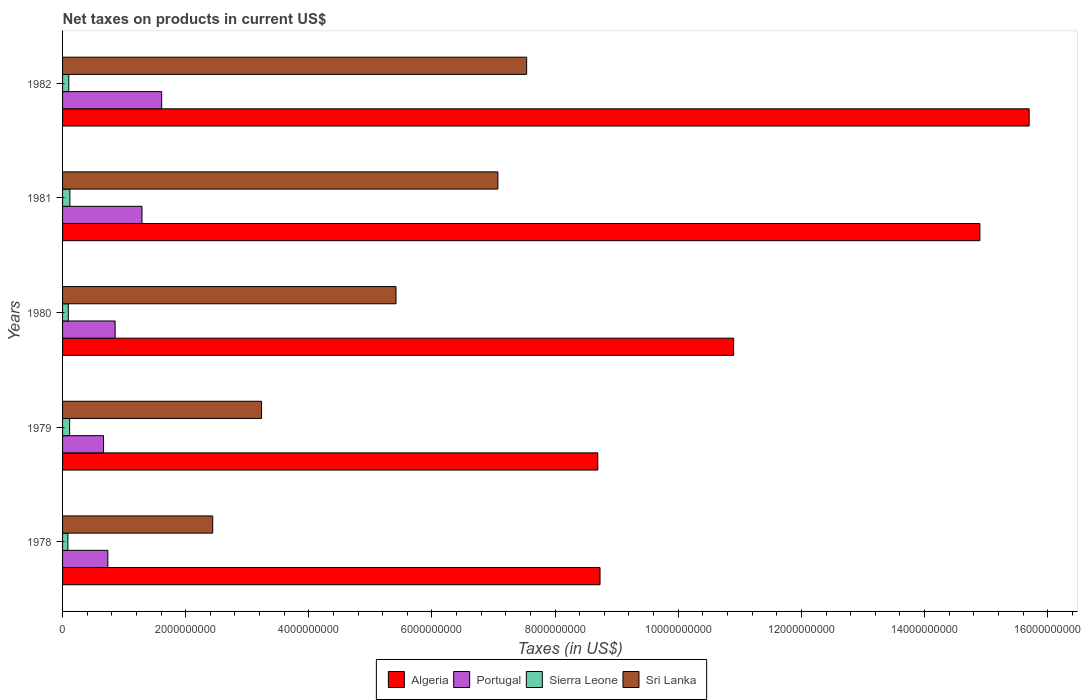Are the number of bars per tick equal to the number of legend labels?
Provide a succinct answer. Yes. Are the number of bars on each tick of the Y-axis equal?
Your response must be concise. Yes. How many bars are there on the 5th tick from the top?
Offer a very short reply. 4. How many bars are there on the 4th tick from the bottom?
Your answer should be very brief. 4. What is the label of the 5th group of bars from the top?
Provide a succinct answer. 1978. In how many cases, is the number of bars for a given year not equal to the number of legend labels?
Offer a very short reply. 0. What is the net taxes on products in Sri Lanka in 1980?
Offer a terse response. 5.42e+09. Across all years, what is the maximum net taxes on products in Algeria?
Give a very brief answer. 1.57e+1. Across all years, what is the minimum net taxes on products in Algeria?
Offer a terse response. 8.69e+09. In which year was the net taxes on products in Portugal maximum?
Ensure brevity in your answer.  1982. In which year was the net taxes on products in Algeria minimum?
Your answer should be compact. 1979. What is the total net taxes on products in Sierra Leone in the graph?
Provide a succinct answer. 5.14e+08. What is the difference between the net taxes on products in Sierra Leone in 1979 and that in 1982?
Your response must be concise. 1.37e+07. What is the difference between the net taxes on products in Portugal in 1981 and the net taxes on products in Algeria in 1979?
Your answer should be very brief. -7.40e+09. What is the average net taxes on products in Algeria per year?
Your answer should be very brief. 1.18e+1. In the year 1982, what is the difference between the net taxes on products in Algeria and net taxes on products in Sri Lanka?
Provide a short and direct response. 8.16e+09. In how many years, is the net taxes on products in Sierra Leone greater than 6400000000 US$?
Your answer should be compact. 0. What is the ratio of the net taxes on products in Algeria in 1981 to that in 1982?
Your answer should be compact. 0.95. What is the difference between the highest and the second highest net taxes on products in Sierra Leone?
Give a very brief answer. 4.32e+06. What is the difference between the highest and the lowest net taxes on products in Sri Lanka?
Give a very brief answer. 5.10e+09. In how many years, is the net taxes on products in Algeria greater than the average net taxes on products in Algeria taken over all years?
Provide a succinct answer. 2. What does the 1st bar from the top in 1978 represents?
Offer a very short reply. Sri Lanka. What does the 4th bar from the bottom in 1979 represents?
Your answer should be compact. Sri Lanka. How many years are there in the graph?
Offer a terse response. 5. Where does the legend appear in the graph?
Your answer should be compact. Bottom center. How many legend labels are there?
Give a very brief answer. 4. What is the title of the graph?
Your answer should be compact. Net taxes on products in current US$. What is the label or title of the X-axis?
Give a very brief answer. Taxes (in US$). What is the label or title of the Y-axis?
Provide a succinct answer. Years. What is the Taxes (in US$) in Algeria in 1978?
Offer a very short reply. 8.73e+09. What is the Taxes (in US$) of Portugal in 1978?
Give a very brief answer. 7.36e+08. What is the Taxes (in US$) in Sierra Leone in 1978?
Offer a very short reply. 8.65e+07. What is the Taxes (in US$) of Sri Lanka in 1978?
Offer a terse response. 2.44e+09. What is the Taxes (in US$) in Algeria in 1979?
Keep it short and to the point. 8.69e+09. What is the Taxes (in US$) of Portugal in 1979?
Offer a very short reply. 6.65e+08. What is the Taxes (in US$) in Sierra Leone in 1979?
Offer a very short reply. 1.15e+08. What is the Taxes (in US$) of Sri Lanka in 1979?
Offer a very short reply. 3.23e+09. What is the Taxes (in US$) in Algeria in 1980?
Your response must be concise. 1.09e+1. What is the Taxes (in US$) of Portugal in 1980?
Give a very brief answer. 8.54e+08. What is the Taxes (in US$) in Sierra Leone in 1980?
Offer a terse response. 9.30e+07. What is the Taxes (in US$) of Sri Lanka in 1980?
Your answer should be compact. 5.42e+09. What is the Taxes (in US$) in Algeria in 1981?
Make the answer very short. 1.49e+1. What is the Taxes (in US$) of Portugal in 1981?
Your response must be concise. 1.29e+09. What is the Taxes (in US$) in Sierra Leone in 1981?
Ensure brevity in your answer.  1.19e+08. What is the Taxes (in US$) of Sri Lanka in 1981?
Give a very brief answer. 7.07e+09. What is the Taxes (in US$) in Algeria in 1982?
Give a very brief answer. 1.57e+1. What is the Taxes (in US$) of Portugal in 1982?
Your response must be concise. 1.61e+09. What is the Taxes (in US$) in Sierra Leone in 1982?
Ensure brevity in your answer.  1.01e+08. What is the Taxes (in US$) in Sri Lanka in 1982?
Your answer should be compact. 7.54e+09. Across all years, what is the maximum Taxes (in US$) in Algeria?
Keep it short and to the point. 1.57e+1. Across all years, what is the maximum Taxes (in US$) of Portugal?
Your answer should be very brief. 1.61e+09. Across all years, what is the maximum Taxes (in US$) of Sierra Leone?
Give a very brief answer. 1.19e+08. Across all years, what is the maximum Taxes (in US$) of Sri Lanka?
Ensure brevity in your answer.  7.54e+09. Across all years, what is the minimum Taxes (in US$) in Algeria?
Your answer should be compact. 8.69e+09. Across all years, what is the minimum Taxes (in US$) of Portugal?
Keep it short and to the point. 6.65e+08. Across all years, what is the minimum Taxes (in US$) of Sierra Leone?
Your answer should be very brief. 8.65e+07. Across all years, what is the minimum Taxes (in US$) in Sri Lanka?
Offer a terse response. 2.44e+09. What is the total Taxes (in US$) of Algeria in the graph?
Provide a succinct answer. 5.89e+1. What is the total Taxes (in US$) in Portugal in the graph?
Provide a succinct answer. 5.15e+09. What is the total Taxes (in US$) in Sierra Leone in the graph?
Your answer should be compact. 5.14e+08. What is the total Taxes (in US$) of Sri Lanka in the graph?
Provide a short and direct response. 2.57e+1. What is the difference between the Taxes (in US$) in Algeria in 1978 and that in 1979?
Provide a succinct answer. 3.64e+07. What is the difference between the Taxes (in US$) in Portugal in 1978 and that in 1979?
Ensure brevity in your answer.  7.03e+07. What is the difference between the Taxes (in US$) in Sierra Leone in 1978 and that in 1979?
Make the answer very short. -2.82e+07. What is the difference between the Taxes (in US$) of Sri Lanka in 1978 and that in 1979?
Offer a very short reply. -7.93e+08. What is the difference between the Taxes (in US$) of Algeria in 1978 and that in 1980?
Keep it short and to the point. -2.17e+09. What is the difference between the Taxes (in US$) of Portugal in 1978 and that in 1980?
Your answer should be very brief. -1.18e+08. What is the difference between the Taxes (in US$) in Sierra Leone in 1978 and that in 1980?
Offer a very short reply. -6.53e+06. What is the difference between the Taxes (in US$) of Sri Lanka in 1978 and that in 1980?
Provide a short and direct response. -2.98e+09. What is the difference between the Taxes (in US$) in Algeria in 1978 and that in 1981?
Offer a terse response. -6.17e+09. What is the difference between the Taxes (in US$) in Portugal in 1978 and that in 1981?
Your answer should be very brief. -5.54e+08. What is the difference between the Taxes (in US$) of Sierra Leone in 1978 and that in 1981?
Offer a very short reply. -3.25e+07. What is the difference between the Taxes (in US$) in Sri Lanka in 1978 and that in 1981?
Give a very brief answer. -4.63e+09. What is the difference between the Taxes (in US$) in Algeria in 1978 and that in 1982?
Offer a very short reply. -6.97e+09. What is the difference between the Taxes (in US$) of Portugal in 1978 and that in 1982?
Provide a short and direct response. -8.74e+08. What is the difference between the Taxes (in US$) in Sierra Leone in 1978 and that in 1982?
Offer a terse response. -1.45e+07. What is the difference between the Taxes (in US$) in Sri Lanka in 1978 and that in 1982?
Your response must be concise. -5.10e+09. What is the difference between the Taxes (in US$) in Algeria in 1979 and that in 1980?
Provide a short and direct response. -2.21e+09. What is the difference between the Taxes (in US$) of Portugal in 1979 and that in 1980?
Make the answer very short. -1.89e+08. What is the difference between the Taxes (in US$) of Sierra Leone in 1979 and that in 1980?
Your answer should be compact. 2.17e+07. What is the difference between the Taxes (in US$) in Sri Lanka in 1979 and that in 1980?
Ensure brevity in your answer.  -2.18e+09. What is the difference between the Taxes (in US$) of Algeria in 1979 and that in 1981?
Your response must be concise. -6.21e+09. What is the difference between the Taxes (in US$) of Portugal in 1979 and that in 1981?
Give a very brief answer. -6.25e+08. What is the difference between the Taxes (in US$) of Sierra Leone in 1979 and that in 1981?
Keep it short and to the point. -4.32e+06. What is the difference between the Taxes (in US$) of Sri Lanka in 1979 and that in 1981?
Give a very brief answer. -3.84e+09. What is the difference between the Taxes (in US$) of Algeria in 1979 and that in 1982?
Your response must be concise. -7.01e+09. What is the difference between the Taxes (in US$) of Portugal in 1979 and that in 1982?
Offer a very short reply. -9.44e+08. What is the difference between the Taxes (in US$) in Sierra Leone in 1979 and that in 1982?
Give a very brief answer. 1.37e+07. What is the difference between the Taxes (in US$) of Sri Lanka in 1979 and that in 1982?
Give a very brief answer. -4.31e+09. What is the difference between the Taxes (in US$) in Algeria in 1980 and that in 1981?
Your answer should be compact. -4.00e+09. What is the difference between the Taxes (in US$) in Portugal in 1980 and that in 1981?
Ensure brevity in your answer.  -4.36e+08. What is the difference between the Taxes (in US$) of Sierra Leone in 1980 and that in 1981?
Offer a terse response. -2.60e+07. What is the difference between the Taxes (in US$) of Sri Lanka in 1980 and that in 1981?
Your answer should be compact. -1.66e+09. What is the difference between the Taxes (in US$) of Algeria in 1980 and that in 1982?
Give a very brief answer. -4.80e+09. What is the difference between the Taxes (in US$) in Portugal in 1980 and that in 1982?
Your answer should be compact. -7.56e+08. What is the difference between the Taxes (in US$) of Sierra Leone in 1980 and that in 1982?
Your answer should be compact. -8.00e+06. What is the difference between the Taxes (in US$) of Sri Lanka in 1980 and that in 1982?
Your answer should be very brief. -2.12e+09. What is the difference between the Taxes (in US$) of Algeria in 1981 and that in 1982?
Keep it short and to the point. -8.00e+08. What is the difference between the Taxes (in US$) in Portugal in 1981 and that in 1982?
Give a very brief answer. -3.20e+08. What is the difference between the Taxes (in US$) in Sierra Leone in 1981 and that in 1982?
Provide a short and direct response. 1.80e+07. What is the difference between the Taxes (in US$) in Sri Lanka in 1981 and that in 1982?
Provide a short and direct response. -4.67e+08. What is the difference between the Taxes (in US$) in Algeria in 1978 and the Taxes (in US$) in Portugal in 1979?
Ensure brevity in your answer.  8.06e+09. What is the difference between the Taxes (in US$) of Algeria in 1978 and the Taxes (in US$) of Sierra Leone in 1979?
Make the answer very short. 8.62e+09. What is the difference between the Taxes (in US$) of Algeria in 1978 and the Taxes (in US$) of Sri Lanka in 1979?
Keep it short and to the point. 5.50e+09. What is the difference between the Taxes (in US$) of Portugal in 1978 and the Taxes (in US$) of Sierra Leone in 1979?
Your answer should be very brief. 6.21e+08. What is the difference between the Taxes (in US$) of Portugal in 1978 and the Taxes (in US$) of Sri Lanka in 1979?
Offer a terse response. -2.50e+09. What is the difference between the Taxes (in US$) in Sierra Leone in 1978 and the Taxes (in US$) in Sri Lanka in 1979?
Ensure brevity in your answer.  -3.15e+09. What is the difference between the Taxes (in US$) in Algeria in 1978 and the Taxes (in US$) in Portugal in 1980?
Ensure brevity in your answer.  7.88e+09. What is the difference between the Taxes (in US$) of Algeria in 1978 and the Taxes (in US$) of Sierra Leone in 1980?
Provide a succinct answer. 8.64e+09. What is the difference between the Taxes (in US$) in Algeria in 1978 and the Taxes (in US$) in Sri Lanka in 1980?
Your answer should be very brief. 3.31e+09. What is the difference between the Taxes (in US$) in Portugal in 1978 and the Taxes (in US$) in Sierra Leone in 1980?
Your answer should be compact. 6.43e+08. What is the difference between the Taxes (in US$) in Portugal in 1978 and the Taxes (in US$) in Sri Lanka in 1980?
Give a very brief answer. -4.68e+09. What is the difference between the Taxes (in US$) in Sierra Leone in 1978 and the Taxes (in US$) in Sri Lanka in 1980?
Offer a terse response. -5.33e+09. What is the difference between the Taxes (in US$) in Algeria in 1978 and the Taxes (in US$) in Portugal in 1981?
Provide a succinct answer. 7.44e+09. What is the difference between the Taxes (in US$) of Algeria in 1978 and the Taxes (in US$) of Sierra Leone in 1981?
Make the answer very short. 8.61e+09. What is the difference between the Taxes (in US$) in Algeria in 1978 and the Taxes (in US$) in Sri Lanka in 1981?
Offer a very short reply. 1.66e+09. What is the difference between the Taxes (in US$) of Portugal in 1978 and the Taxes (in US$) of Sierra Leone in 1981?
Keep it short and to the point. 6.17e+08. What is the difference between the Taxes (in US$) in Portugal in 1978 and the Taxes (in US$) in Sri Lanka in 1981?
Your answer should be compact. -6.34e+09. What is the difference between the Taxes (in US$) in Sierra Leone in 1978 and the Taxes (in US$) in Sri Lanka in 1981?
Keep it short and to the point. -6.98e+09. What is the difference between the Taxes (in US$) of Algeria in 1978 and the Taxes (in US$) of Portugal in 1982?
Your answer should be compact. 7.12e+09. What is the difference between the Taxes (in US$) in Algeria in 1978 and the Taxes (in US$) in Sierra Leone in 1982?
Offer a very short reply. 8.63e+09. What is the difference between the Taxes (in US$) in Algeria in 1978 and the Taxes (in US$) in Sri Lanka in 1982?
Make the answer very short. 1.19e+09. What is the difference between the Taxes (in US$) in Portugal in 1978 and the Taxes (in US$) in Sierra Leone in 1982?
Your response must be concise. 6.35e+08. What is the difference between the Taxes (in US$) of Portugal in 1978 and the Taxes (in US$) of Sri Lanka in 1982?
Your response must be concise. -6.80e+09. What is the difference between the Taxes (in US$) of Sierra Leone in 1978 and the Taxes (in US$) of Sri Lanka in 1982?
Make the answer very short. -7.45e+09. What is the difference between the Taxes (in US$) of Algeria in 1979 and the Taxes (in US$) of Portugal in 1980?
Your response must be concise. 7.84e+09. What is the difference between the Taxes (in US$) of Algeria in 1979 and the Taxes (in US$) of Sierra Leone in 1980?
Provide a succinct answer. 8.60e+09. What is the difference between the Taxes (in US$) in Algeria in 1979 and the Taxes (in US$) in Sri Lanka in 1980?
Ensure brevity in your answer.  3.28e+09. What is the difference between the Taxes (in US$) of Portugal in 1979 and the Taxes (in US$) of Sierra Leone in 1980?
Provide a short and direct response. 5.72e+08. What is the difference between the Taxes (in US$) of Portugal in 1979 and the Taxes (in US$) of Sri Lanka in 1980?
Keep it short and to the point. -4.75e+09. What is the difference between the Taxes (in US$) of Sierra Leone in 1979 and the Taxes (in US$) of Sri Lanka in 1980?
Make the answer very short. -5.30e+09. What is the difference between the Taxes (in US$) in Algeria in 1979 and the Taxes (in US$) in Portugal in 1981?
Offer a terse response. 7.40e+09. What is the difference between the Taxes (in US$) in Algeria in 1979 and the Taxes (in US$) in Sierra Leone in 1981?
Provide a short and direct response. 8.57e+09. What is the difference between the Taxes (in US$) of Algeria in 1979 and the Taxes (in US$) of Sri Lanka in 1981?
Your response must be concise. 1.62e+09. What is the difference between the Taxes (in US$) in Portugal in 1979 and the Taxes (in US$) in Sierra Leone in 1981?
Your response must be concise. 5.46e+08. What is the difference between the Taxes (in US$) of Portugal in 1979 and the Taxes (in US$) of Sri Lanka in 1981?
Offer a terse response. -6.41e+09. What is the difference between the Taxes (in US$) of Sierra Leone in 1979 and the Taxes (in US$) of Sri Lanka in 1981?
Provide a short and direct response. -6.96e+09. What is the difference between the Taxes (in US$) of Algeria in 1979 and the Taxes (in US$) of Portugal in 1982?
Your answer should be very brief. 7.08e+09. What is the difference between the Taxes (in US$) of Algeria in 1979 and the Taxes (in US$) of Sierra Leone in 1982?
Provide a short and direct response. 8.59e+09. What is the difference between the Taxes (in US$) of Algeria in 1979 and the Taxes (in US$) of Sri Lanka in 1982?
Your answer should be very brief. 1.16e+09. What is the difference between the Taxes (in US$) of Portugal in 1979 and the Taxes (in US$) of Sierra Leone in 1982?
Offer a very short reply. 5.64e+08. What is the difference between the Taxes (in US$) of Portugal in 1979 and the Taxes (in US$) of Sri Lanka in 1982?
Your answer should be compact. -6.87e+09. What is the difference between the Taxes (in US$) of Sierra Leone in 1979 and the Taxes (in US$) of Sri Lanka in 1982?
Your answer should be very brief. -7.42e+09. What is the difference between the Taxes (in US$) in Algeria in 1980 and the Taxes (in US$) in Portugal in 1981?
Your answer should be very brief. 9.61e+09. What is the difference between the Taxes (in US$) of Algeria in 1980 and the Taxes (in US$) of Sierra Leone in 1981?
Make the answer very short. 1.08e+1. What is the difference between the Taxes (in US$) of Algeria in 1980 and the Taxes (in US$) of Sri Lanka in 1981?
Ensure brevity in your answer.  3.83e+09. What is the difference between the Taxes (in US$) of Portugal in 1980 and the Taxes (in US$) of Sierra Leone in 1981?
Your response must be concise. 7.35e+08. What is the difference between the Taxes (in US$) in Portugal in 1980 and the Taxes (in US$) in Sri Lanka in 1981?
Keep it short and to the point. -6.22e+09. What is the difference between the Taxes (in US$) in Sierra Leone in 1980 and the Taxes (in US$) in Sri Lanka in 1981?
Offer a terse response. -6.98e+09. What is the difference between the Taxes (in US$) of Algeria in 1980 and the Taxes (in US$) of Portugal in 1982?
Offer a terse response. 9.29e+09. What is the difference between the Taxes (in US$) in Algeria in 1980 and the Taxes (in US$) in Sierra Leone in 1982?
Your response must be concise. 1.08e+1. What is the difference between the Taxes (in US$) in Algeria in 1980 and the Taxes (in US$) in Sri Lanka in 1982?
Your response must be concise. 3.36e+09. What is the difference between the Taxes (in US$) of Portugal in 1980 and the Taxes (in US$) of Sierra Leone in 1982?
Give a very brief answer. 7.53e+08. What is the difference between the Taxes (in US$) of Portugal in 1980 and the Taxes (in US$) of Sri Lanka in 1982?
Provide a succinct answer. -6.68e+09. What is the difference between the Taxes (in US$) of Sierra Leone in 1980 and the Taxes (in US$) of Sri Lanka in 1982?
Give a very brief answer. -7.44e+09. What is the difference between the Taxes (in US$) of Algeria in 1981 and the Taxes (in US$) of Portugal in 1982?
Offer a very short reply. 1.33e+1. What is the difference between the Taxes (in US$) in Algeria in 1981 and the Taxes (in US$) in Sierra Leone in 1982?
Offer a terse response. 1.48e+1. What is the difference between the Taxes (in US$) of Algeria in 1981 and the Taxes (in US$) of Sri Lanka in 1982?
Give a very brief answer. 7.36e+09. What is the difference between the Taxes (in US$) in Portugal in 1981 and the Taxes (in US$) in Sierra Leone in 1982?
Keep it short and to the point. 1.19e+09. What is the difference between the Taxes (in US$) in Portugal in 1981 and the Taxes (in US$) in Sri Lanka in 1982?
Keep it short and to the point. -6.25e+09. What is the difference between the Taxes (in US$) of Sierra Leone in 1981 and the Taxes (in US$) of Sri Lanka in 1982?
Offer a terse response. -7.42e+09. What is the average Taxes (in US$) in Algeria per year?
Offer a terse response. 1.18e+1. What is the average Taxes (in US$) of Portugal per year?
Your answer should be very brief. 1.03e+09. What is the average Taxes (in US$) of Sierra Leone per year?
Your answer should be very brief. 1.03e+08. What is the average Taxes (in US$) of Sri Lanka per year?
Provide a short and direct response. 5.14e+09. In the year 1978, what is the difference between the Taxes (in US$) in Algeria and Taxes (in US$) in Portugal?
Keep it short and to the point. 7.99e+09. In the year 1978, what is the difference between the Taxes (in US$) in Algeria and Taxes (in US$) in Sierra Leone?
Offer a terse response. 8.64e+09. In the year 1978, what is the difference between the Taxes (in US$) in Algeria and Taxes (in US$) in Sri Lanka?
Offer a very short reply. 6.29e+09. In the year 1978, what is the difference between the Taxes (in US$) of Portugal and Taxes (in US$) of Sierra Leone?
Your answer should be compact. 6.49e+08. In the year 1978, what is the difference between the Taxes (in US$) in Portugal and Taxes (in US$) in Sri Lanka?
Provide a short and direct response. -1.70e+09. In the year 1978, what is the difference between the Taxes (in US$) in Sierra Leone and Taxes (in US$) in Sri Lanka?
Your response must be concise. -2.35e+09. In the year 1979, what is the difference between the Taxes (in US$) in Algeria and Taxes (in US$) in Portugal?
Keep it short and to the point. 8.03e+09. In the year 1979, what is the difference between the Taxes (in US$) in Algeria and Taxes (in US$) in Sierra Leone?
Give a very brief answer. 8.58e+09. In the year 1979, what is the difference between the Taxes (in US$) of Algeria and Taxes (in US$) of Sri Lanka?
Provide a short and direct response. 5.46e+09. In the year 1979, what is the difference between the Taxes (in US$) of Portugal and Taxes (in US$) of Sierra Leone?
Your answer should be compact. 5.51e+08. In the year 1979, what is the difference between the Taxes (in US$) of Portugal and Taxes (in US$) of Sri Lanka?
Offer a terse response. -2.57e+09. In the year 1979, what is the difference between the Taxes (in US$) in Sierra Leone and Taxes (in US$) in Sri Lanka?
Make the answer very short. -3.12e+09. In the year 1980, what is the difference between the Taxes (in US$) in Algeria and Taxes (in US$) in Portugal?
Your answer should be very brief. 1.00e+1. In the year 1980, what is the difference between the Taxes (in US$) of Algeria and Taxes (in US$) of Sierra Leone?
Make the answer very short. 1.08e+1. In the year 1980, what is the difference between the Taxes (in US$) in Algeria and Taxes (in US$) in Sri Lanka?
Provide a succinct answer. 5.48e+09. In the year 1980, what is the difference between the Taxes (in US$) of Portugal and Taxes (in US$) of Sierra Leone?
Your answer should be compact. 7.61e+08. In the year 1980, what is the difference between the Taxes (in US$) of Portugal and Taxes (in US$) of Sri Lanka?
Provide a short and direct response. -4.56e+09. In the year 1980, what is the difference between the Taxes (in US$) in Sierra Leone and Taxes (in US$) in Sri Lanka?
Ensure brevity in your answer.  -5.32e+09. In the year 1981, what is the difference between the Taxes (in US$) in Algeria and Taxes (in US$) in Portugal?
Make the answer very short. 1.36e+1. In the year 1981, what is the difference between the Taxes (in US$) in Algeria and Taxes (in US$) in Sierra Leone?
Give a very brief answer. 1.48e+1. In the year 1981, what is the difference between the Taxes (in US$) in Algeria and Taxes (in US$) in Sri Lanka?
Offer a terse response. 7.83e+09. In the year 1981, what is the difference between the Taxes (in US$) in Portugal and Taxes (in US$) in Sierra Leone?
Provide a short and direct response. 1.17e+09. In the year 1981, what is the difference between the Taxes (in US$) of Portugal and Taxes (in US$) of Sri Lanka?
Your answer should be compact. -5.78e+09. In the year 1981, what is the difference between the Taxes (in US$) of Sierra Leone and Taxes (in US$) of Sri Lanka?
Offer a very short reply. -6.95e+09. In the year 1982, what is the difference between the Taxes (in US$) in Algeria and Taxes (in US$) in Portugal?
Give a very brief answer. 1.41e+1. In the year 1982, what is the difference between the Taxes (in US$) of Algeria and Taxes (in US$) of Sierra Leone?
Provide a short and direct response. 1.56e+1. In the year 1982, what is the difference between the Taxes (in US$) of Algeria and Taxes (in US$) of Sri Lanka?
Provide a short and direct response. 8.16e+09. In the year 1982, what is the difference between the Taxes (in US$) in Portugal and Taxes (in US$) in Sierra Leone?
Your response must be concise. 1.51e+09. In the year 1982, what is the difference between the Taxes (in US$) of Portugal and Taxes (in US$) of Sri Lanka?
Your answer should be compact. -5.93e+09. In the year 1982, what is the difference between the Taxes (in US$) of Sierra Leone and Taxes (in US$) of Sri Lanka?
Keep it short and to the point. -7.44e+09. What is the ratio of the Taxes (in US$) in Portugal in 1978 to that in 1979?
Your response must be concise. 1.11. What is the ratio of the Taxes (in US$) in Sierra Leone in 1978 to that in 1979?
Make the answer very short. 0.75. What is the ratio of the Taxes (in US$) of Sri Lanka in 1978 to that in 1979?
Give a very brief answer. 0.75. What is the ratio of the Taxes (in US$) of Algeria in 1978 to that in 1980?
Your answer should be compact. 0.8. What is the ratio of the Taxes (in US$) in Portugal in 1978 to that in 1980?
Provide a short and direct response. 0.86. What is the ratio of the Taxes (in US$) in Sierra Leone in 1978 to that in 1980?
Your response must be concise. 0.93. What is the ratio of the Taxes (in US$) of Sri Lanka in 1978 to that in 1980?
Offer a terse response. 0.45. What is the ratio of the Taxes (in US$) in Algeria in 1978 to that in 1981?
Keep it short and to the point. 0.59. What is the ratio of the Taxes (in US$) of Portugal in 1978 to that in 1981?
Your answer should be very brief. 0.57. What is the ratio of the Taxes (in US$) of Sierra Leone in 1978 to that in 1981?
Your answer should be very brief. 0.73. What is the ratio of the Taxes (in US$) of Sri Lanka in 1978 to that in 1981?
Your response must be concise. 0.34. What is the ratio of the Taxes (in US$) in Algeria in 1978 to that in 1982?
Your answer should be compact. 0.56. What is the ratio of the Taxes (in US$) of Portugal in 1978 to that in 1982?
Your answer should be compact. 0.46. What is the ratio of the Taxes (in US$) of Sierra Leone in 1978 to that in 1982?
Make the answer very short. 0.86. What is the ratio of the Taxes (in US$) in Sri Lanka in 1978 to that in 1982?
Your response must be concise. 0.32. What is the ratio of the Taxes (in US$) of Algeria in 1979 to that in 1980?
Provide a succinct answer. 0.8. What is the ratio of the Taxes (in US$) in Portugal in 1979 to that in 1980?
Provide a succinct answer. 0.78. What is the ratio of the Taxes (in US$) in Sierra Leone in 1979 to that in 1980?
Your answer should be compact. 1.23. What is the ratio of the Taxes (in US$) in Sri Lanka in 1979 to that in 1980?
Keep it short and to the point. 0.6. What is the ratio of the Taxes (in US$) of Algeria in 1979 to that in 1981?
Your answer should be compact. 0.58. What is the ratio of the Taxes (in US$) of Portugal in 1979 to that in 1981?
Keep it short and to the point. 0.52. What is the ratio of the Taxes (in US$) in Sierra Leone in 1979 to that in 1981?
Your answer should be very brief. 0.96. What is the ratio of the Taxes (in US$) of Sri Lanka in 1979 to that in 1981?
Ensure brevity in your answer.  0.46. What is the ratio of the Taxes (in US$) of Algeria in 1979 to that in 1982?
Offer a very short reply. 0.55. What is the ratio of the Taxes (in US$) in Portugal in 1979 to that in 1982?
Offer a very short reply. 0.41. What is the ratio of the Taxes (in US$) in Sierra Leone in 1979 to that in 1982?
Ensure brevity in your answer.  1.14. What is the ratio of the Taxes (in US$) of Sri Lanka in 1979 to that in 1982?
Keep it short and to the point. 0.43. What is the ratio of the Taxes (in US$) in Algeria in 1980 to that in 1981?
Your answer should be very brief. 0.73. What is the ratio of the Taxes (in US$) in Portugal in 1980 to that in 1981?
Ensure brevity in your answer.  0.66. What is the ratio of the Taxes (in US$) in Sierra Leone in 1980 to that in 1981?
Provide a succinct answer. 0.78. What is the ratio of the Taxes (in US$) of Sri Lanka in 1980 to that in 1981?
Keep it short and to the point. 0.77. What is the ratio of the Taxes (in US$) of Algeria in 1980 to that in 1982?
Provide a short and direct response. 0.69. What is the ratio of the Taxes (in US$) in Portugal in 1980 to that in 1982?
Make the answer very short. 0.53. What is the ratio of the Taxes (in US$) in Sierra Leone in 1980 to that in 1982?
Provide a short and direct response. 0.92. What is the ratio of the Taxes (in US$) in Sri Lanka in 1980 to that in 1982?
Keep it short and to the point. 0.72. What is the ratio of the Taxes (in US$) of Algeria in 1981 to that in 1982?
Offer a very short reply. 0.95. What is the ratio of the Taxes (in US$) in Portugal in 1981 to that in 1982?
Provide a short and direct response. 0.8. What is the ratio of the Taxes (in US$) in Sierra Leone in 1981 to that in 1982?
Give a very brief answer. 1.18. What is the ratio of the Taxes (in US$) in Sri Lanka in 1981 to that in 1982?
Your answer should be very brief. 0.94. What is the difference between the highest and the second highest Taxes (in US$) in Algeria?
Your response must be concise. 8.00e+08. What is the difference between the highest and the second highest Taxes (in US$) in Portugal?
Keep it short and to the point. 3.20e+08. What is the difference between the highest and the second highest Taxes (in US$) of Sierra Leone?
Provide a short and direct response. 4.32e+06. What is the difference between the highest and the second highest Taxes (in US$) of Sri Lanka?
Give a very brief answer. 4.67e+08. What is the difference between the highest and the lowest Taxes (in US$) in Algeria?
Give a very brief answer. 7.01e+09. What is the difference between the highest and the lowest Taxes (in US$) of Portugal?
Your answer should be very brief. 9.44e+08. What is the difference between the highest and the lowest Taxes (in US$) of Sierra Leone?
Make the answer very short. 3.25e+07. What is the difference between the highest and the lowest Taxes (in US$) in Sri Lanka?
Offer a very short reply. 5.10e+09. 